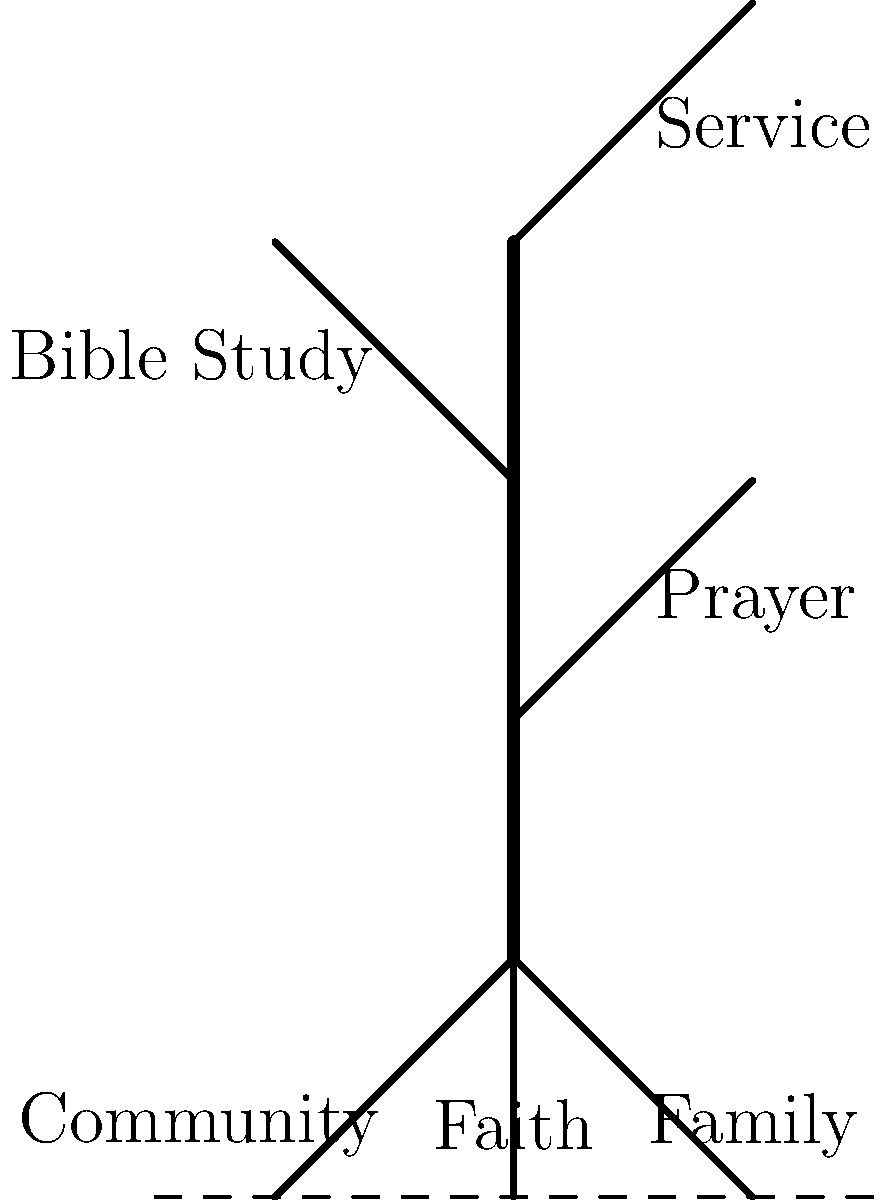In the plant metaphor diagram of faith growth, which element is represented by the trunk of the plant, serving as the main channel for spiritual nourishment and growth? To answer this question, let's analyze the plant metaphor diagram step-by-step:

1. The diagram shows a plant structure with roots, a trunk, and branches.

2. The roots are labeled with foundational elements of faith:
   - Faith
   - Community
   - Family

3. The branches are labeled with practices that contribute to spiritual growth:
   - Prayer
   - Bible Study
   - Service

4. The trunk is the central, vertical element connecting the roots to the branches.

5. In plant biology, the trunk serves as the main channel for water and nutrients to flow from the roots to the rest of the plant.

6. In this faith metaphor, the trunk would represent the primary conduit for spiritual nourishment and growth.

7. Given that the question asks about the main channel for spiritual nourishment and growth, and considering the structure of the plant, the trunk is the most logical answer.

8. The trunk, while not explicitly labeled, represents the core connection between the foundational elements (roots) and the growth practices (branches).

Therefore, the trunk in this plant metaphor diagram represents the main channel for spiritual nourishment and growth in one's faith journey.
Answer: The trunk 